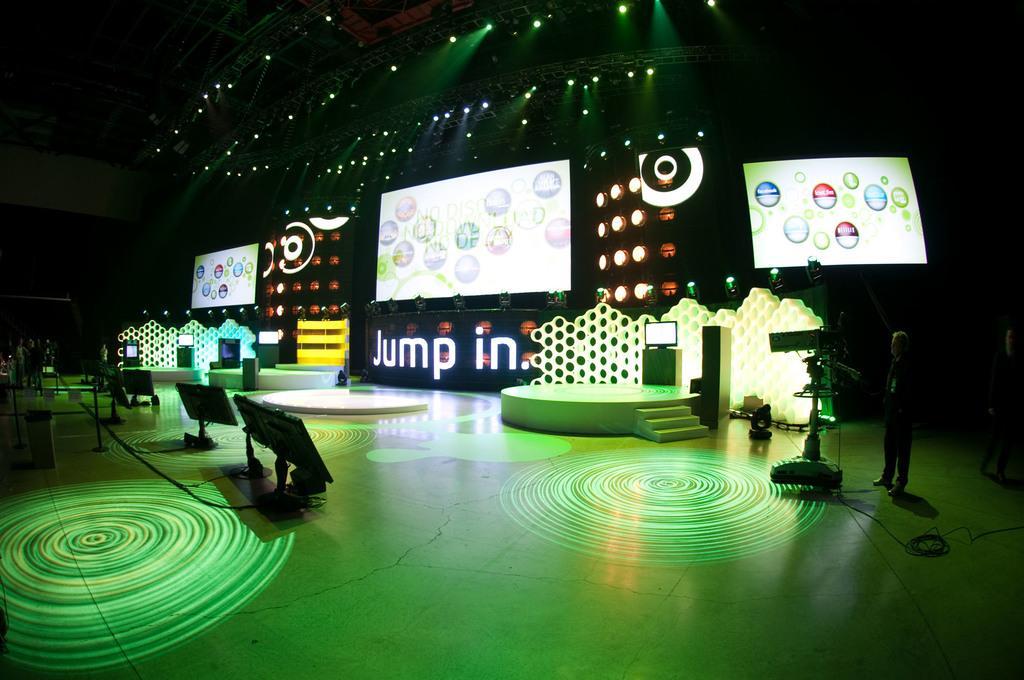Can you describe this image briefly? In this image we can see three screens. Here we can see the televisions on the table. Here we can see a man standing on the floor and he is on the right side. Here we can see three people on the left side. Here we can see the lighting arrangement on the roof. 